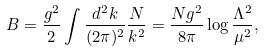<formula> <loc_0><loc_0><loc_500><loc_500>B = \frac { g ^ { 2 } } { 2 } \int \frac { d ^ { 2 } k } { ( 2 \pi ) ^ { 2 } } \frac { N } { k ^ { 2 } } = \frac { N g ^ { 2 } } { 8 \pi } \log { \frac { \Lambda ^ { 2 } } { \mu ^ { 2 } } } ,</formula> 